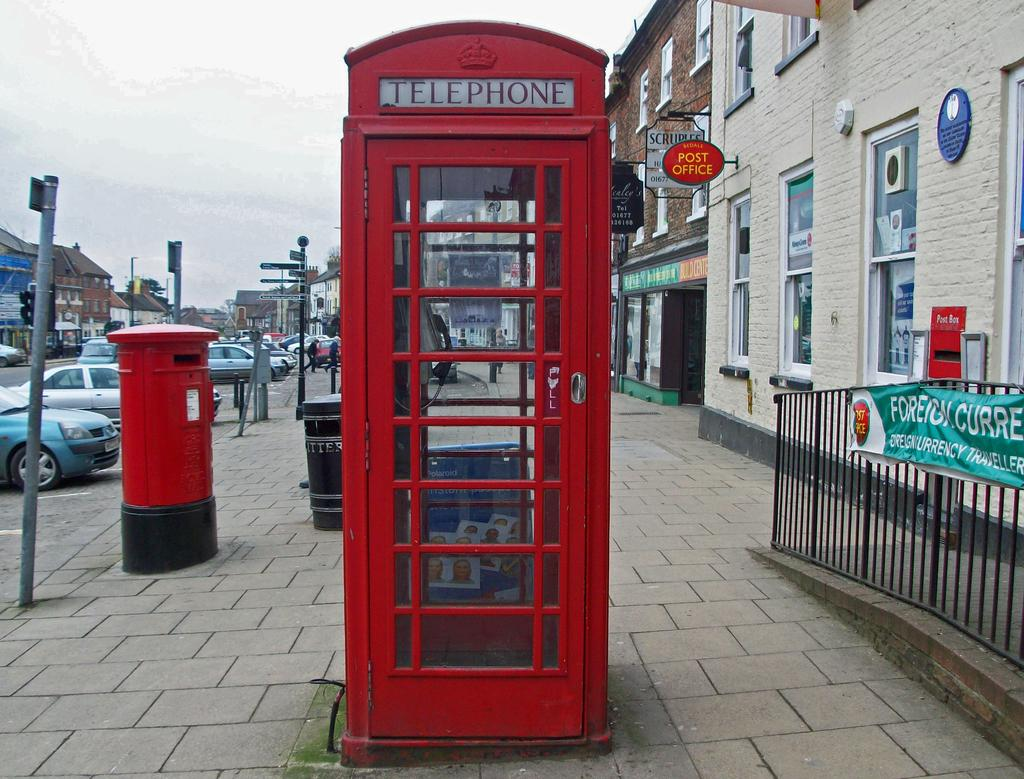<image>
Present a compact description of the photo's key features. a red UK telephone box in front of a post office. 